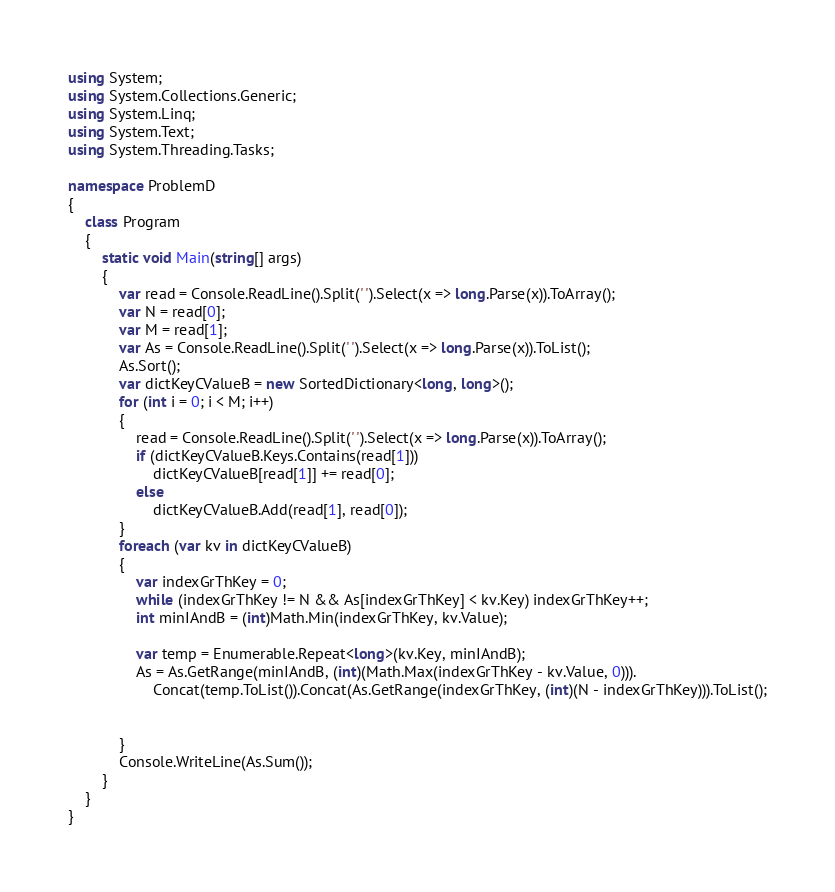Convert code to text. <code><loc_0><loc_0><loc_500><loc_500><_C#_>using System;
using System.Collections.Generic;
using System.Linq;
using System.Text;
using System.Threading.Tasks;

namespace ProblemD
{
    class Program
    {
        static void Main(string[] args)
        {
            var read = Console.ReadLine().Split(' ').Select(x => long.Parse(x)).ToArray();
            var N = read[0];
            var M = read[1];
            var As = Console.ReadLine().Split(' ').Select(x => long.Parse(x)).ToList();
            As.Sort();
            var dictKeyCValueB = new SortedDictionary<long, long>();
            for (int i = 0; i < M; i++)
            {
                read = Console.ReadLine().Split(' ').Select(x => long.Parse(x)).ToArray();
                if (dictKeyCValueB.Keys.Contains(read[1]))
                    dictKeyCValueB[read[1]] += read[0];
                else
                    dictKeyCValueB.Add(read[1], read[0]);
            }
            foreach (var kv in dictKeyCValueB)
            {
                var indexGrThKey = 0;
                while (indexGrThKey != N && As[indexGrThKey] < kv.Key) indexGrThKey++;
                int minIAndB = (int)Math.Min(indexGrThKey, kv.Value);

                var temp = Enumerable.Repeat<long>(kv.Key, minIAndB);
                As = As.GetRange(minIAndB, (int)(Math.Max(indexGrThKey - kv.Value, 0))).
                    Concat(temp.ToList()).Concat(As.GetRange(indexGrThKey, (int)(N - indexGrThKey))).ToList();


            }
            Console.WriteLine(As.Sum());
        }
    }
}
</code> 